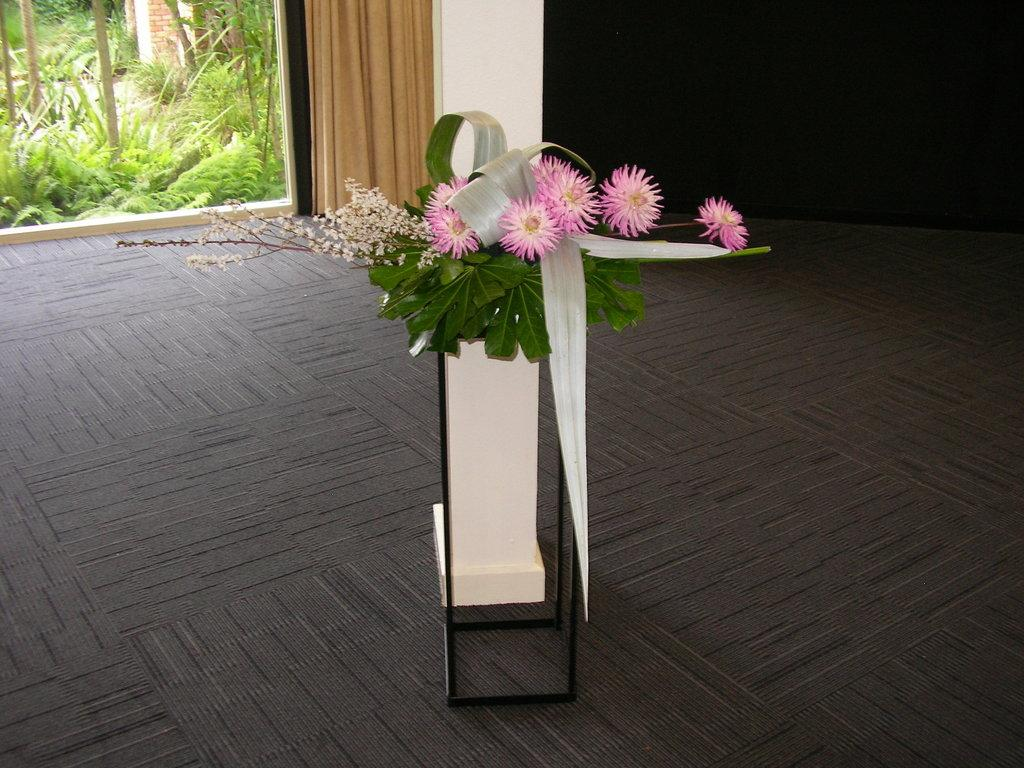What is contained within the object in the image? There are flowers in an object in the image. What can be seen beneath the object? The ground is visible in the image. What is present behind the object? There is a wall in the image. What material is partially transparent in the image? There is some glass visible in the image. What type of vegetation is present in the image? There are plants in the image. What type of bread can be seen hanging from the wall in the image? There is no bread present in the image, and nothing is hanging from the wall. 